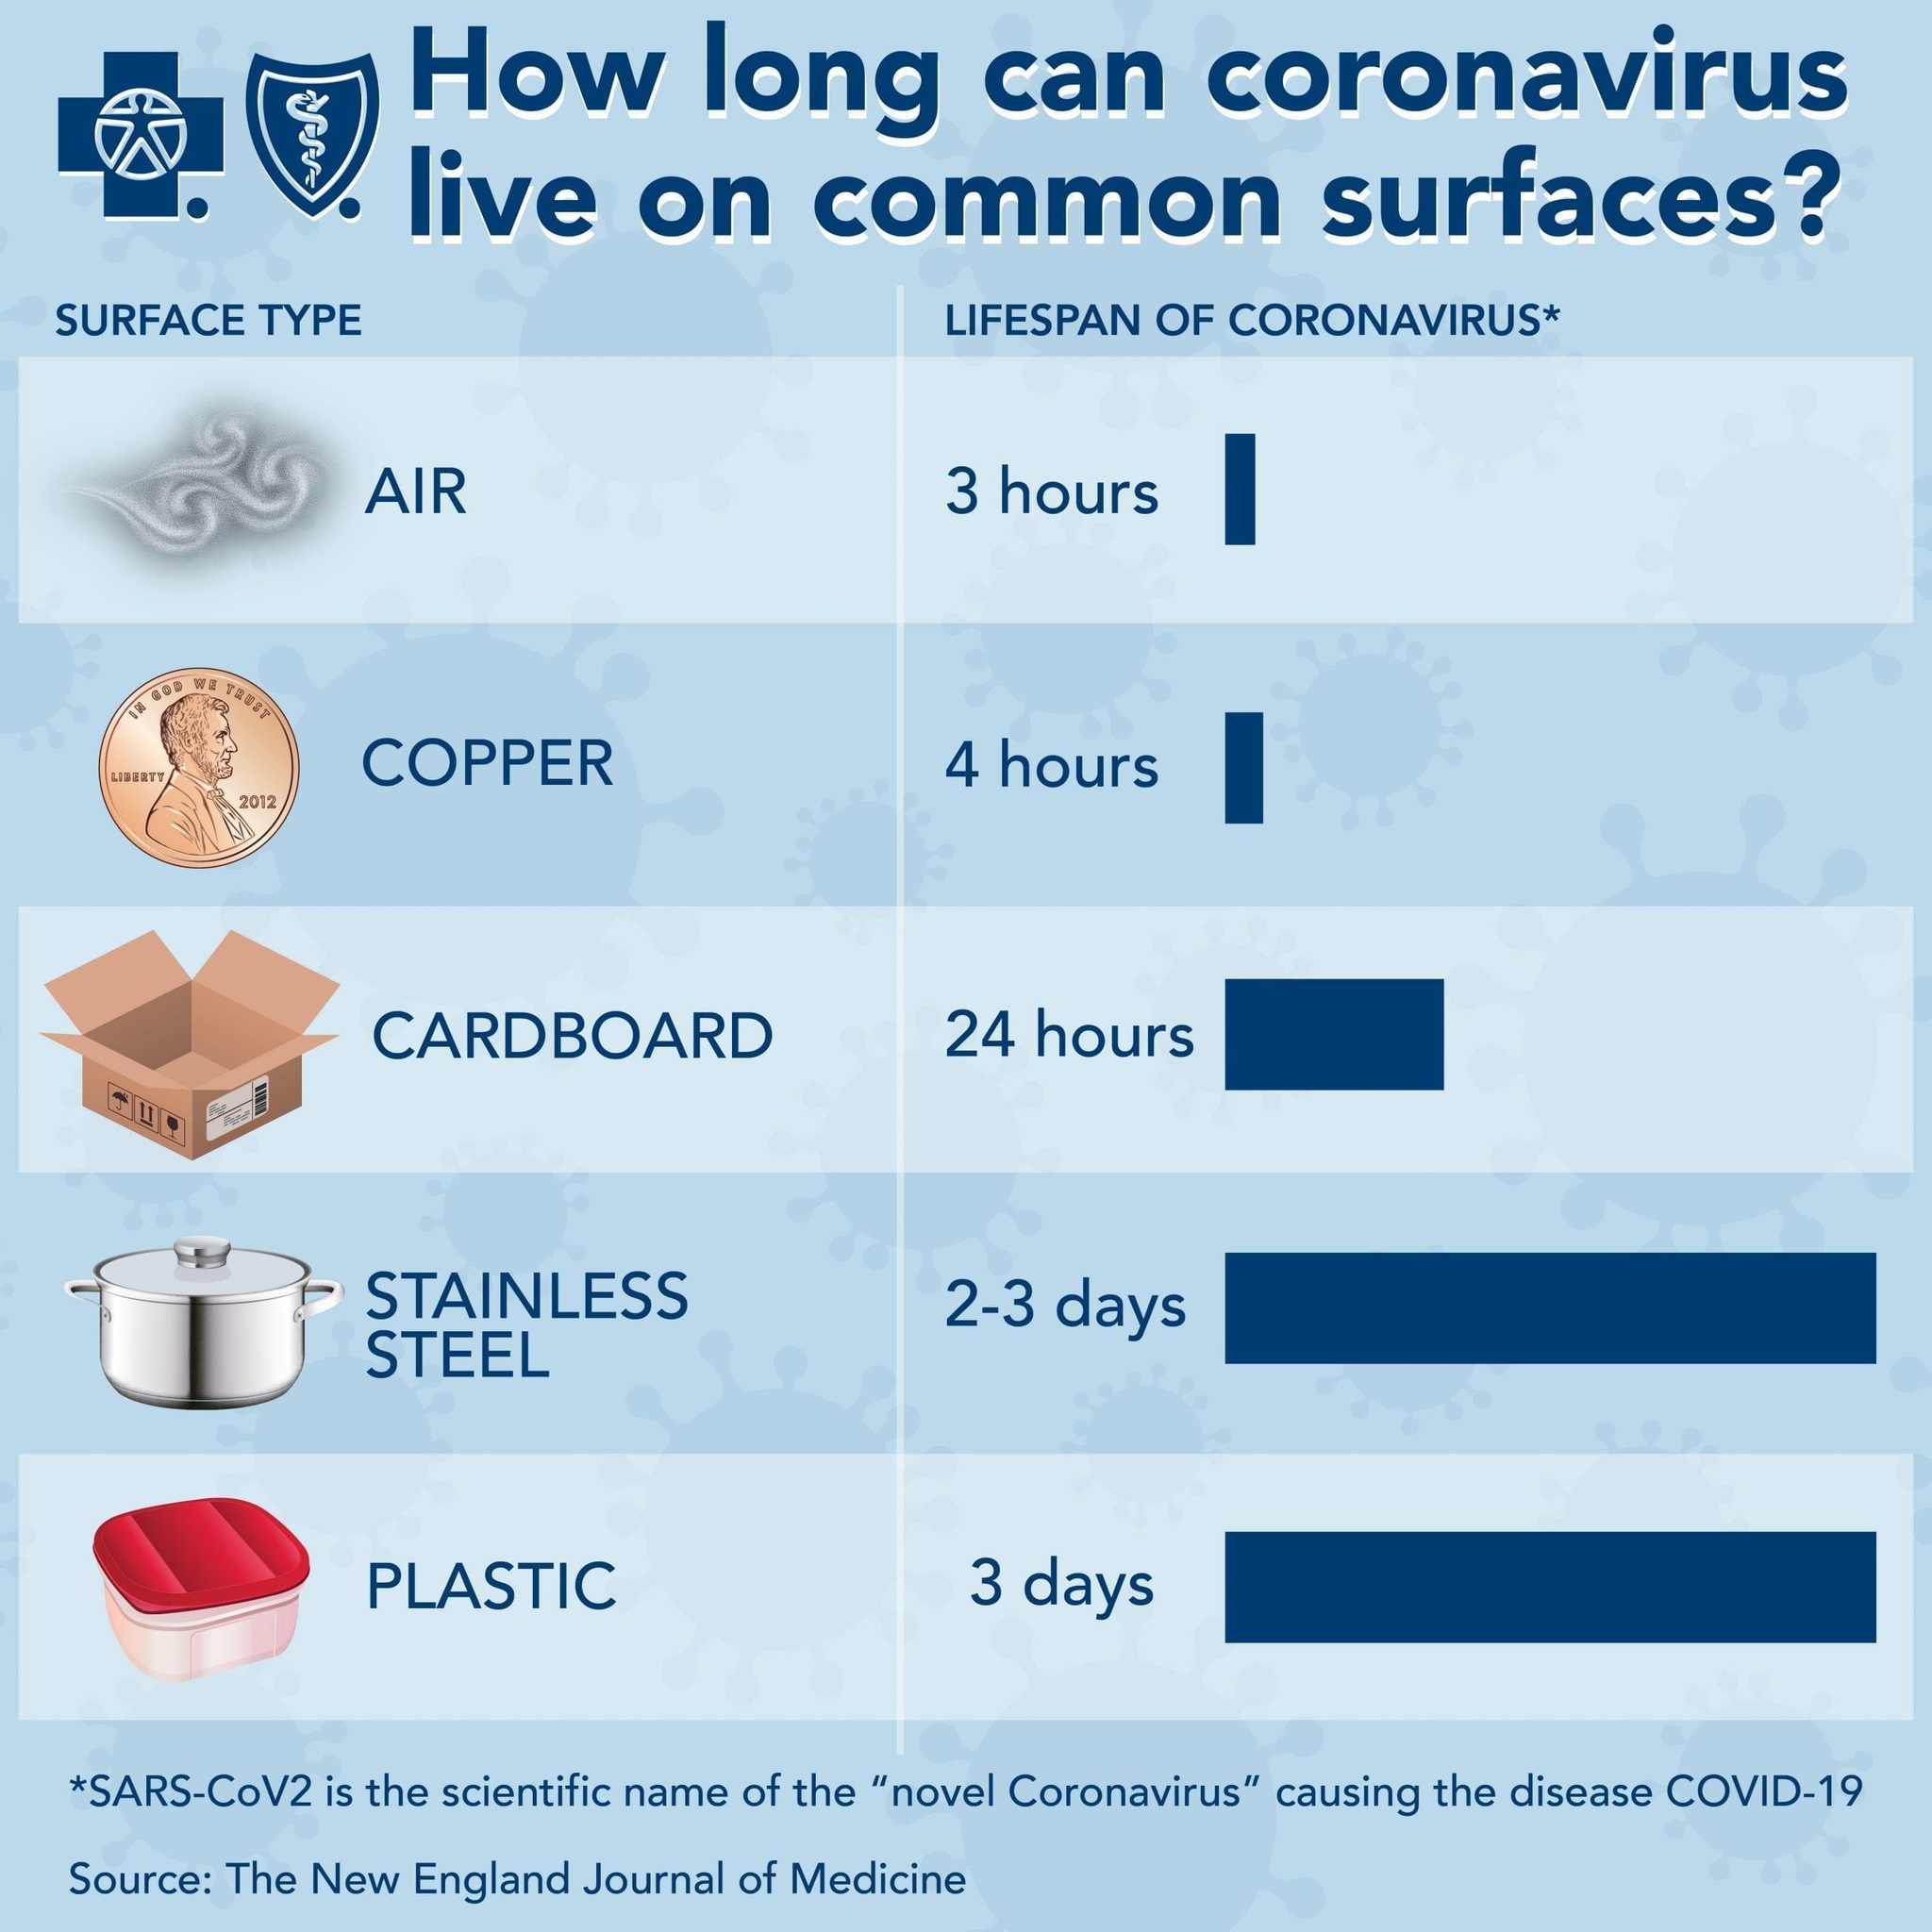In which surface coronavirus has a short lifespan?
Answer the question with a short phrase. Air In which surface corona has the second shortest lifespan? Copper 